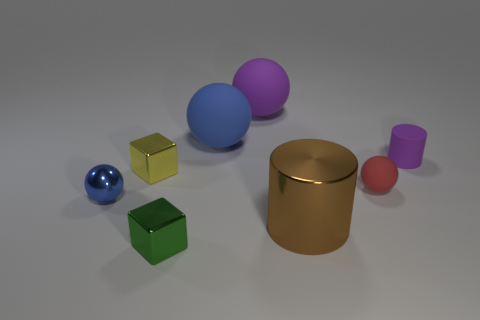Can you describe the colors of the objects in the image? Certainly! There are two blue spheres, a yellow and a green cube, a gold cylindrical object, a purple sphere, a pink cylinder, and a small red sphere. 